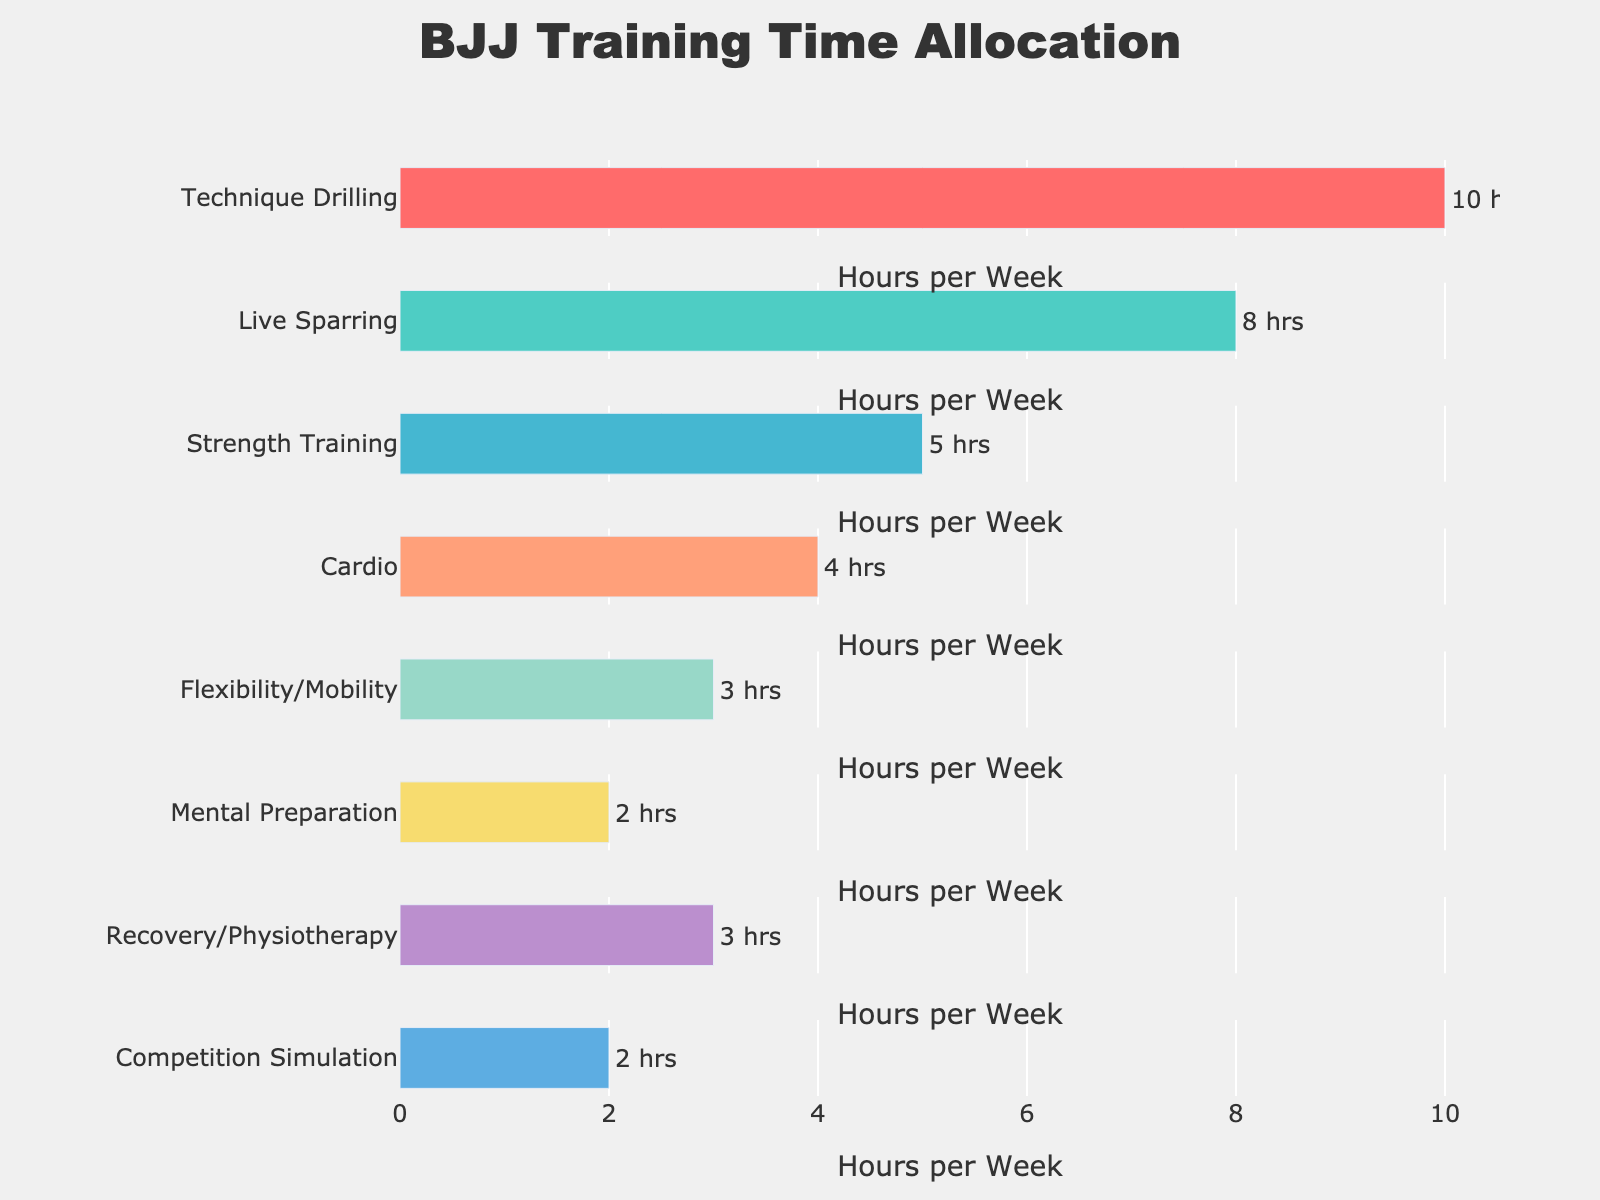What's the title of the plot? The title is located at the top of the plot, typically in larger, bold font. By looking at the figure, you can read the main heading that describes what the plot is about.
Answer: BJJ Training Time Allocation How many hours are allocated to Live Sparring per week? Locate the bar corresponding to Live Sparring on the figure; the x-axis shows the number of hours, and the value may be annotated on the bar itself.
Answer: 8 Which two aspects of BJJ training have the fewest hours allocated per week? Observe the length of the bars and identify the shortest ones. Compare these to determine which aspects have the lowest values.
Answer: Mental Preparation and Competition Simulation How much more time is spent on Technique Drilling compared to Cardio per week? Find the hours for Technique Drilling and Cardio, subtract the Cardio hours from the Technique Drilling hours to get the difference.
Answer: 6 What's the total number of hours allocated to Recovery/Physiotherapy and Flexibility/Mobility together per week? Locate the bars for Recovery/Physiotherapy and Flexibility/Mobility, add their corresponding hours to get the sum.
Answer: 6 Which training aspect has the highest number of hours allocated per week? Look for the longest bar on the plot and identify the aspect it represents.
Answer: Technique Drilling Are the hours spent on Live Sparring greater than, less than, or equal to the hours spent on Technique Drilling? Compare the lengths of the bars for Live Sparring and Technique Drilling to determine the relationship.
Answer: Less than What is the median number of hours allocated across all the aspects shown? List all hours, sort them in ascending order, and find the middle value. If there are an odd number of hours, it's the middle one; if even, it's the average of the two middle numbers.
Answer: 4.5 By how many hours does the combined time for Strength Training and Cardio exceed the time for Mental Preparation and Competition Simulation? Add the hours for Strength Training and Cardio, then for Mental Preparation and Competition Simulation, and subtract the latter sum from the former.
Answer: 5 